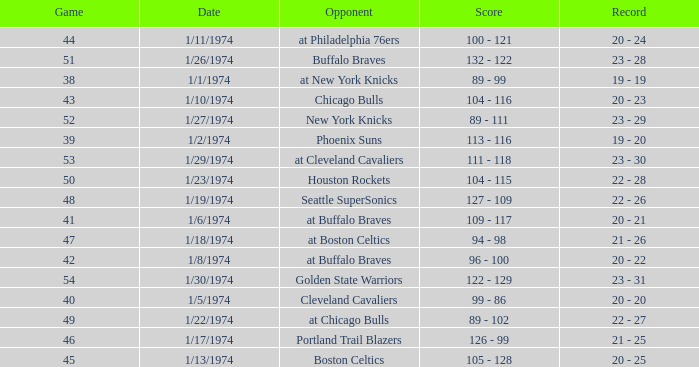What was the record after game 51 on 1/27/1974? 23 - 29. 